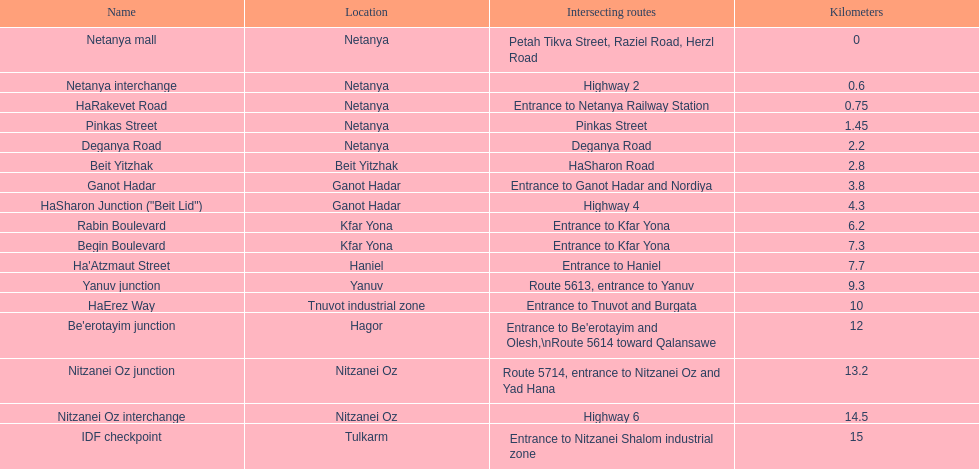How many sections intersect highway 2? 1. 